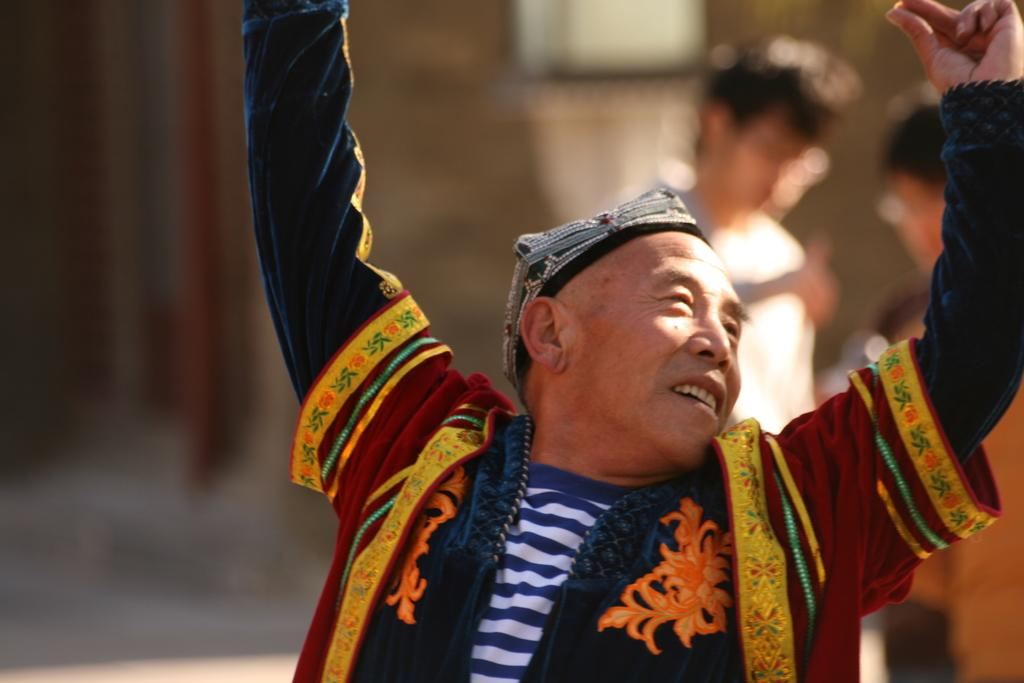What is the person in the image wearing? The person in the image is wearing buddhist attire. What is the person doing in the image? The person is standing and raising their hands. Can you describe the background of the image? The background is blurred, and there are other persons visible in the background. What type of water can be seen flowing in the image? There is no water visible in the image. Can you describe the snake that is slithering in the background of the image? There is no snake present in the image. 